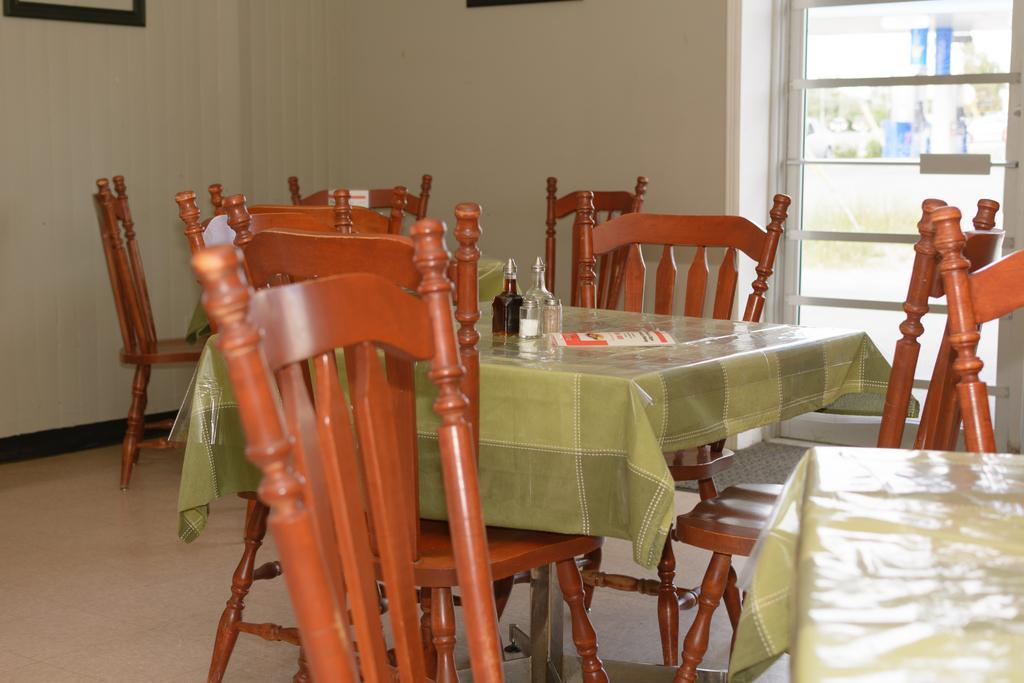How would you summarize this image in a sentence or two? In this picture I can see the tables and chairs and on this table I see 2 bottles and I see the floor. In the background I see the wall and I see the window on the right side. 